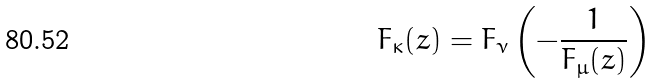Convert formula to latex. <formula><loc_0><loc_0><loc_500><loc_500>F _ { \kappa } ( z ) = F _ { \nu } \left ( - \frac { 1 } { F _ { \mu } ( z ) } \right )</formula> 